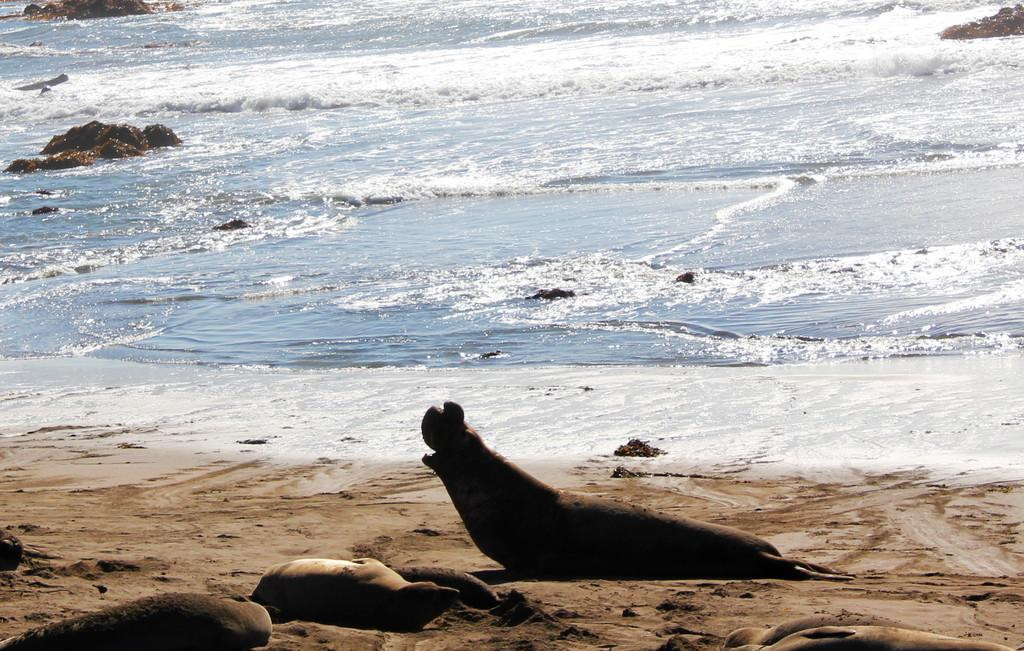What animals can be seen on the sand in the image? There are sea lions on the sand in the image. What type of environment is visible in the background? There is water visible in the background. What geological features are present in the image? There are rocks present in the image. What type of house can be seen in the image? There is no house present in the image; it features sea lions on the sand with water and rocks in the background. 